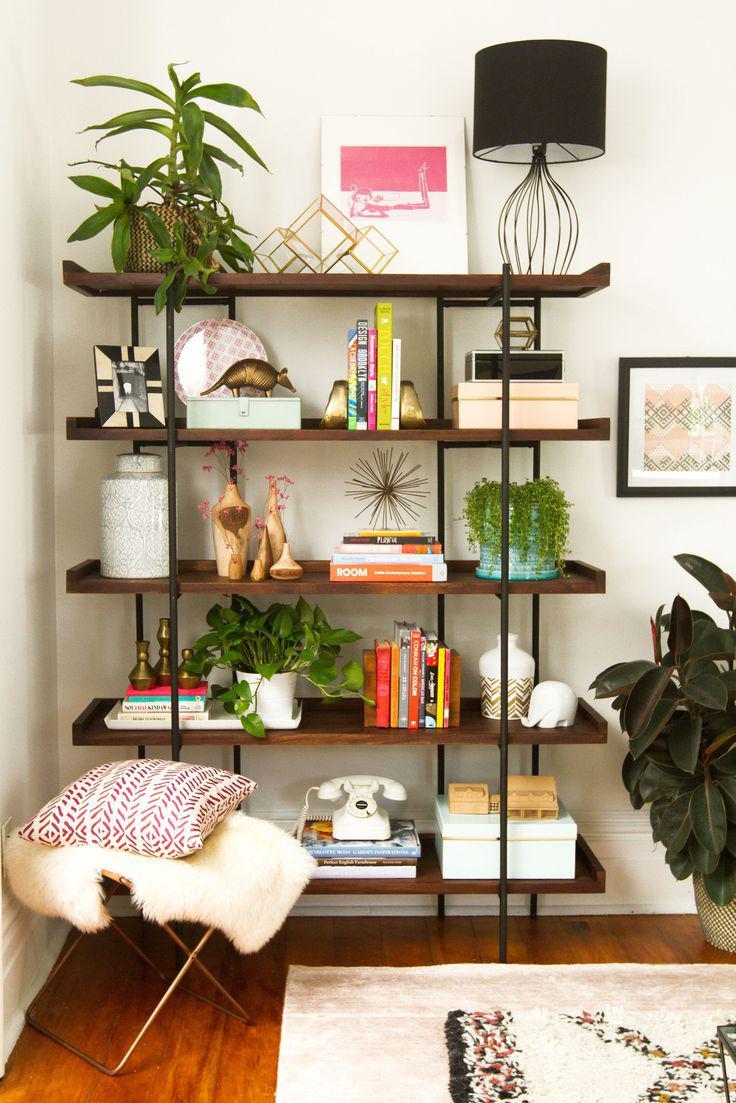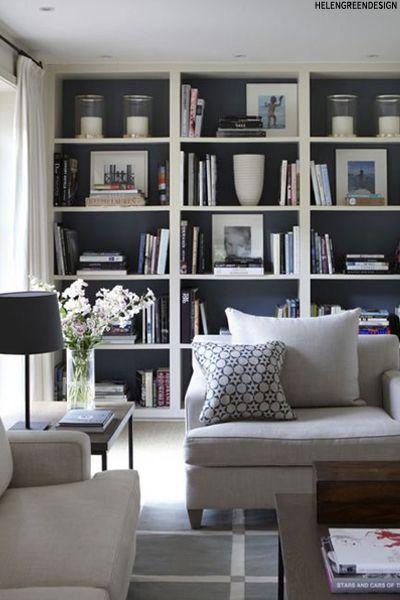The first image is the image on the left, the second image is the image on the right. Assess this claim about the two images: "In one image, a television is centered in a white wall unit that has open shelving in the upper section and solid panel doors and drawers across the bottom". Correct or not? Answer yes or no. No. The first image is the image on the left, the second image is the image on the right. Given the left and right images, does the statement "A large flat-screen TV is flanked by vertical white bookshelves in one of the rooms." hold true? Answer yes or no. No. 